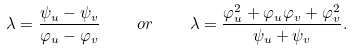Convert formula to latex. <formula><loc_0><loc_0><loc_500><loc_500>\lambda = \frac { \psi _ { u } - \psi _ { v } } { \varphi _ { u } - \varphi _ { v } } \quad o r \quad \lambda = \frac { \varphi _ { u } ^ { 2 } + \varphi _ { u } \varphi _ { v } + \varphi _ { v } ^ { 2 } } { \psi _ { u } + \psi _ { v } } .</formula> 